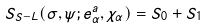<formula> <loc_0><loc_0><loc_500><loc_500>S _ { S - L } ( \sigma , \psi ; e ^ { a } _ { \alpha } , \chi _ { \alpha } ) = S _ { 0 } + S _ { 1 }</formula> 